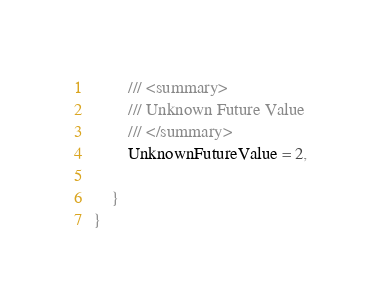Convert code to text. <code><loc_0><loc_0><loc_500><loc_500><_C#_>        /// <summary>
        /// Unknown Future Value
        /// </summary>
        UnknownFutureValue = 2,
	
    }
}
</code> 